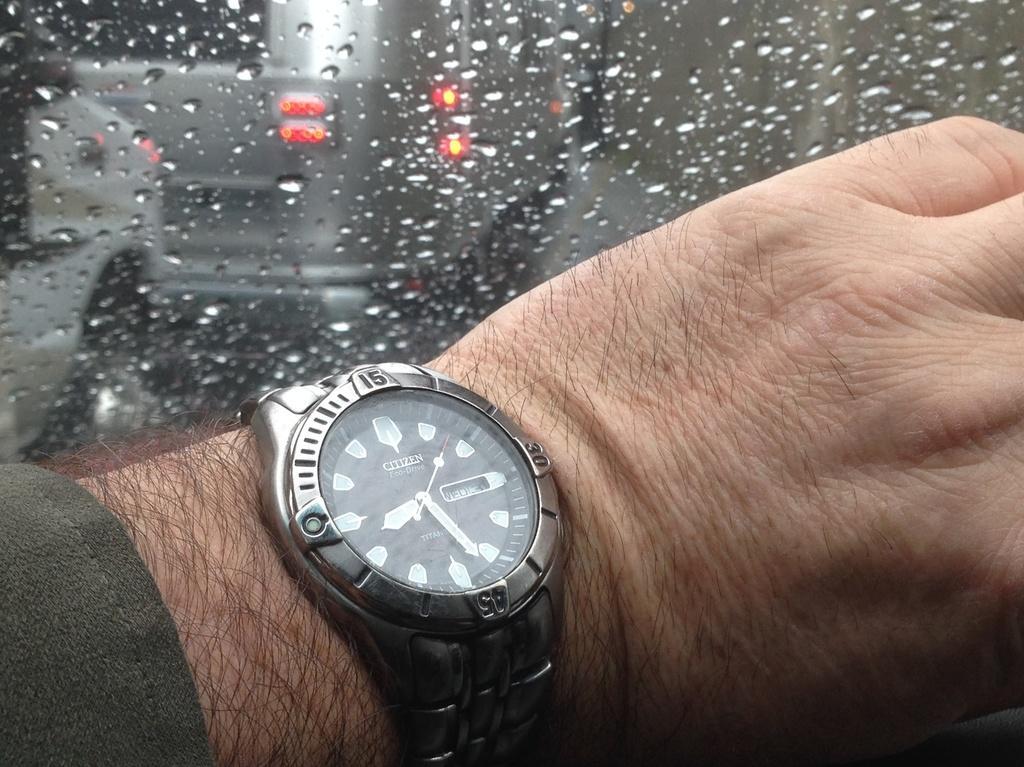In one or two sentences, can you explain what this image depicts? In front of the picture, we see the hand of the man wearing a watch. Behind that, we see a glass from which we can see the car moving on the road. It might be raining outside. 